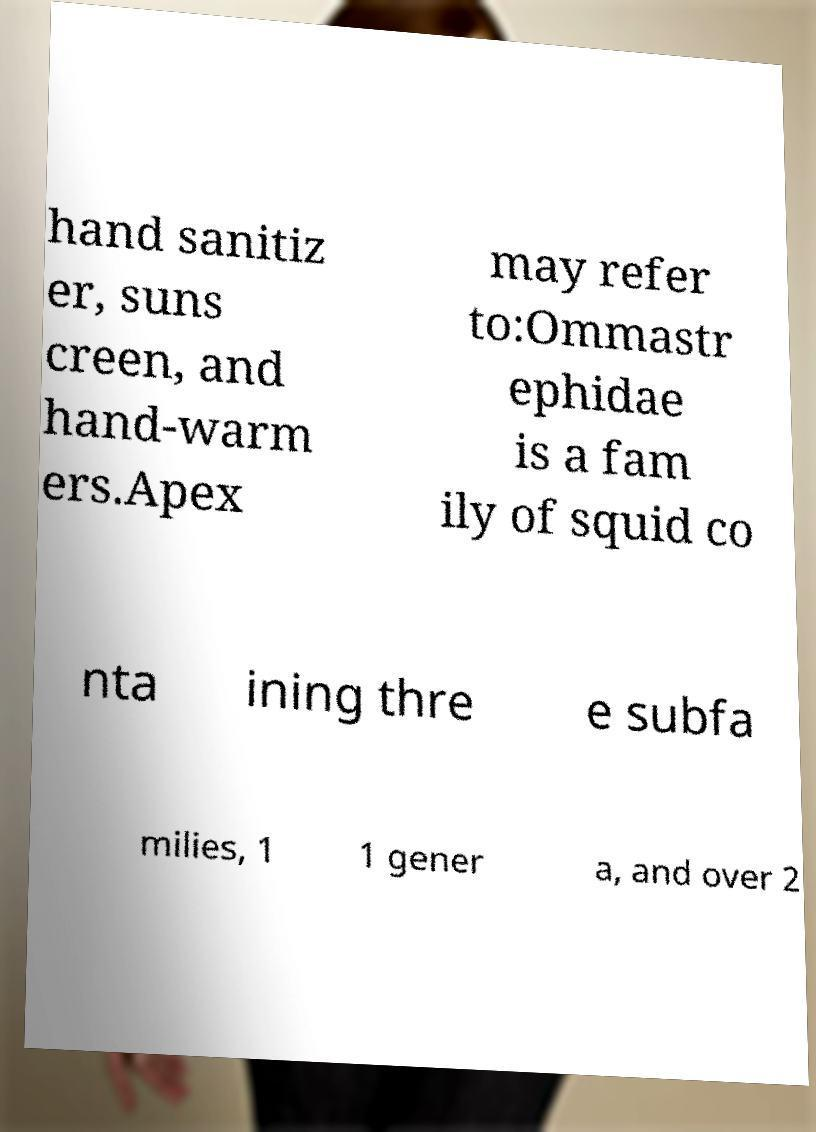Please identify and transcribe the text found in this image. hand sanitiz er, suns creen, and hand-warm ers.Apex may refer to:Ommastr ephidae is a fam ily of squid co nta ining thre e subfa milies, 1 1 gener a, and over 2 